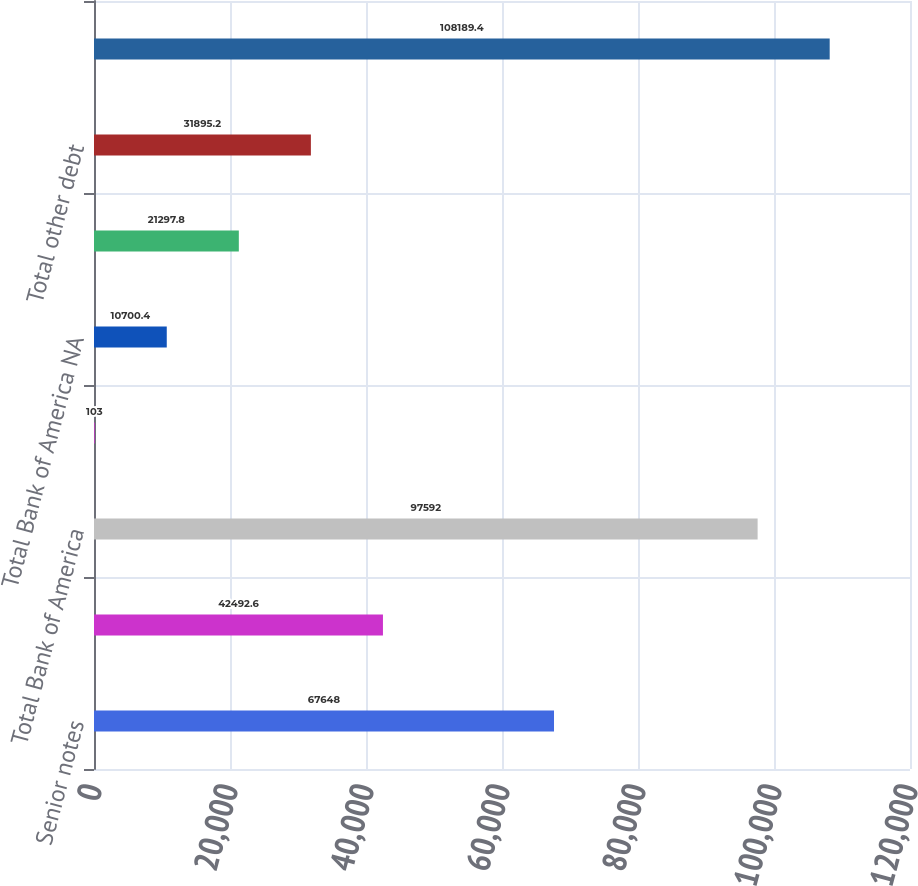Convert chart to OTSL. <chart><loc_0><loc_0><loc_500><loc_500><bar_chart><fcel>Senior notes<fcel>Senior structured notes<fcel>Total Bank of America<fcel>Advances from Federal Home<fcel>Total Bank of America NA<fcel>Structured liabilities<fcel>Total other debt<fcel>Total long-term debt<nl><fcel>67648<fcel>42492.6<fcel>97592<fcel>103<fcel>10700.4<fcel>21297.8<fcel>31895.2<fcel>108189<nl></chart> 